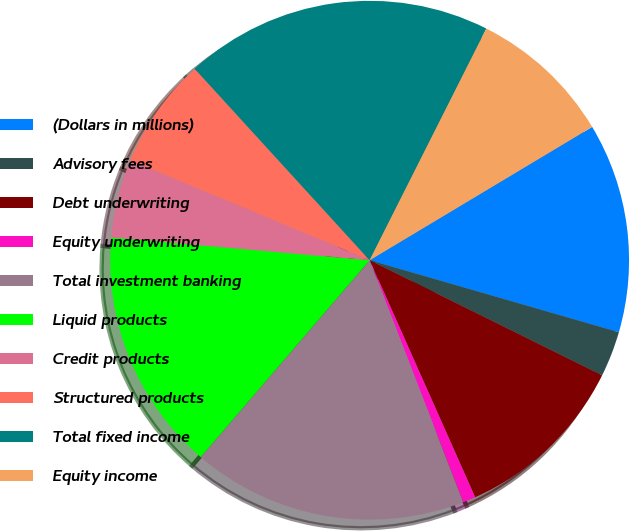Convert chart. <chart><loc_0><loc_0><loc_500><loc_500><pie_chart><fcel>(Dollars in millions)<fcel>Advisory fees<fcel>Debt underwriting<fcel>Equity underwriting<fcel>Total investment banking<fcel>Liquid products<fcel>Credit products<fcel>Structured products<fcel>Total fixed income<fcel>Equity income<nl><fcel>13.07%<fcel>2.84%<fcel>11.02%<fcel>0.79%<fcel>17.16%<fcel>15.12%<fcel>4.88%<fcel>6.93%<fcel>19.21%<fcel>8.98%<nl></chart> 